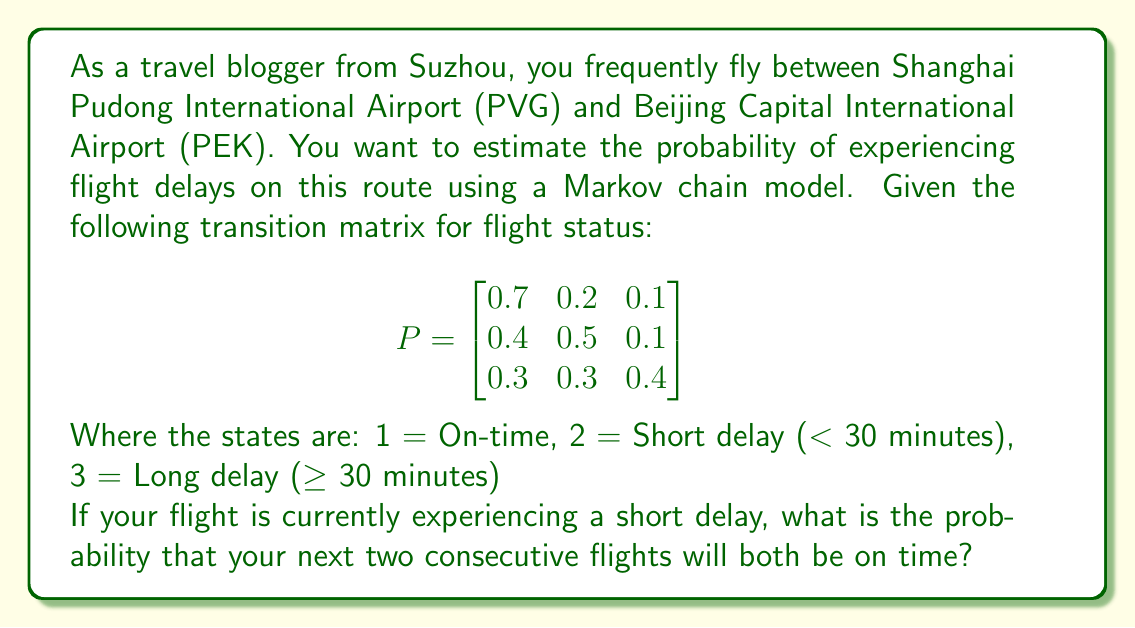Provide a solution to this math problem. Let's approach this step-by-step:

1) We start in state 2 (Short delay) and want to calculate the probability of transitioning to state 1 (On-time) for two consecutive flights.

2) For the first transition (from short delay to on-time), we need the probability in row 2, column 1 of the transition matrix. This is $P_{21} = 0.4$.

3) For the second transition (from on-time to on-time again), we need the probability in row 1, column 1. This is $P_{11} = 0.7$.

4) The probability of both events occurring is the product of their individual probabilities:

   $P(\text{On-time and then On-time | Short delay}) = P_{21} \times P_{11}$

5) Substituting the values:

   $P(\text{On-time and then On-time | Short delay}) = 0.4 \times 0.7 = 0.28$

Therefore, the probability that your next two consecutive flights will both be on time, given that your current flight has a short delay, is 0.28 or 28%.
Answer: 0.28 